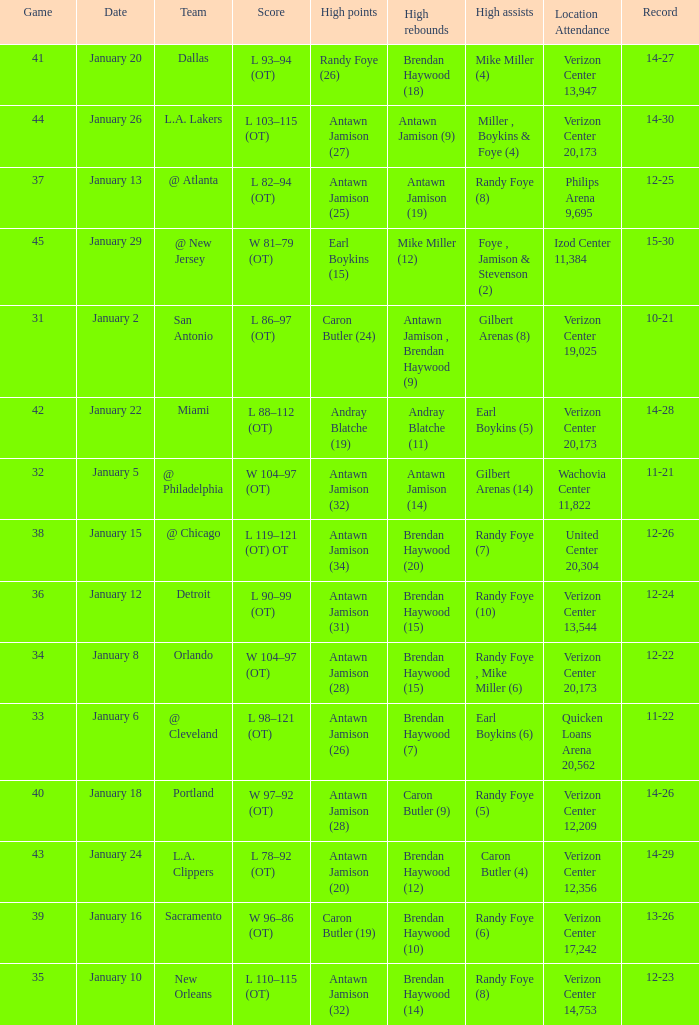How many people got high points in game 35? 1.0. 